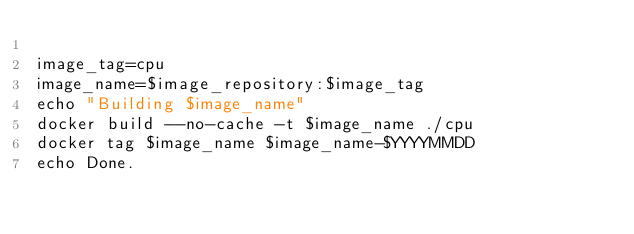<code> <loc_0><loc_0><loc_500><loc_500><_Bash_>
image_tag=cpu
image_name=$image_repository:$image_tag
echo "Building $image_name"
docker build --no-cache -t $image_name ./cpu
docker tag $image_name $image_name-$YYYYMMDD
echo Done.
</code> 